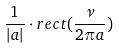<formula> <loc_0><loc_0><loc_500><loc_500>\frac { 1 } { | a | } \cdot r e c t ( \frac { \nu } { 2 \pi a } )</formula> 